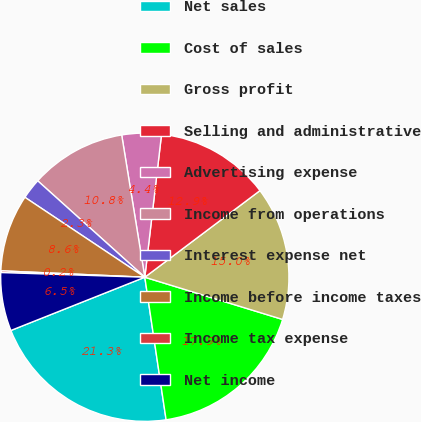Convert chart to OTSL. <chart><loc_0><loc_0><loc_500><loc_500><pie_chart><fcel>Net sales<fcel>Cost of sales<fcel>Gross profit<fcel>Selling and administrative<fcel>Advertising expense<fcel>Income from operations<fcel>Interest expense net<fcel>Income before income taxes<fcel>Income tax expense<fcel>Net income<nl><fcel>21.34%<fcel>17.91%<fcel>15.0%<fcel>12.88%<fcel>4.42%<fcel>10.77%<fcel>2.31%<fcel>8.65%<fcel>0.19%<fcel>6.54%<nl></chart> 